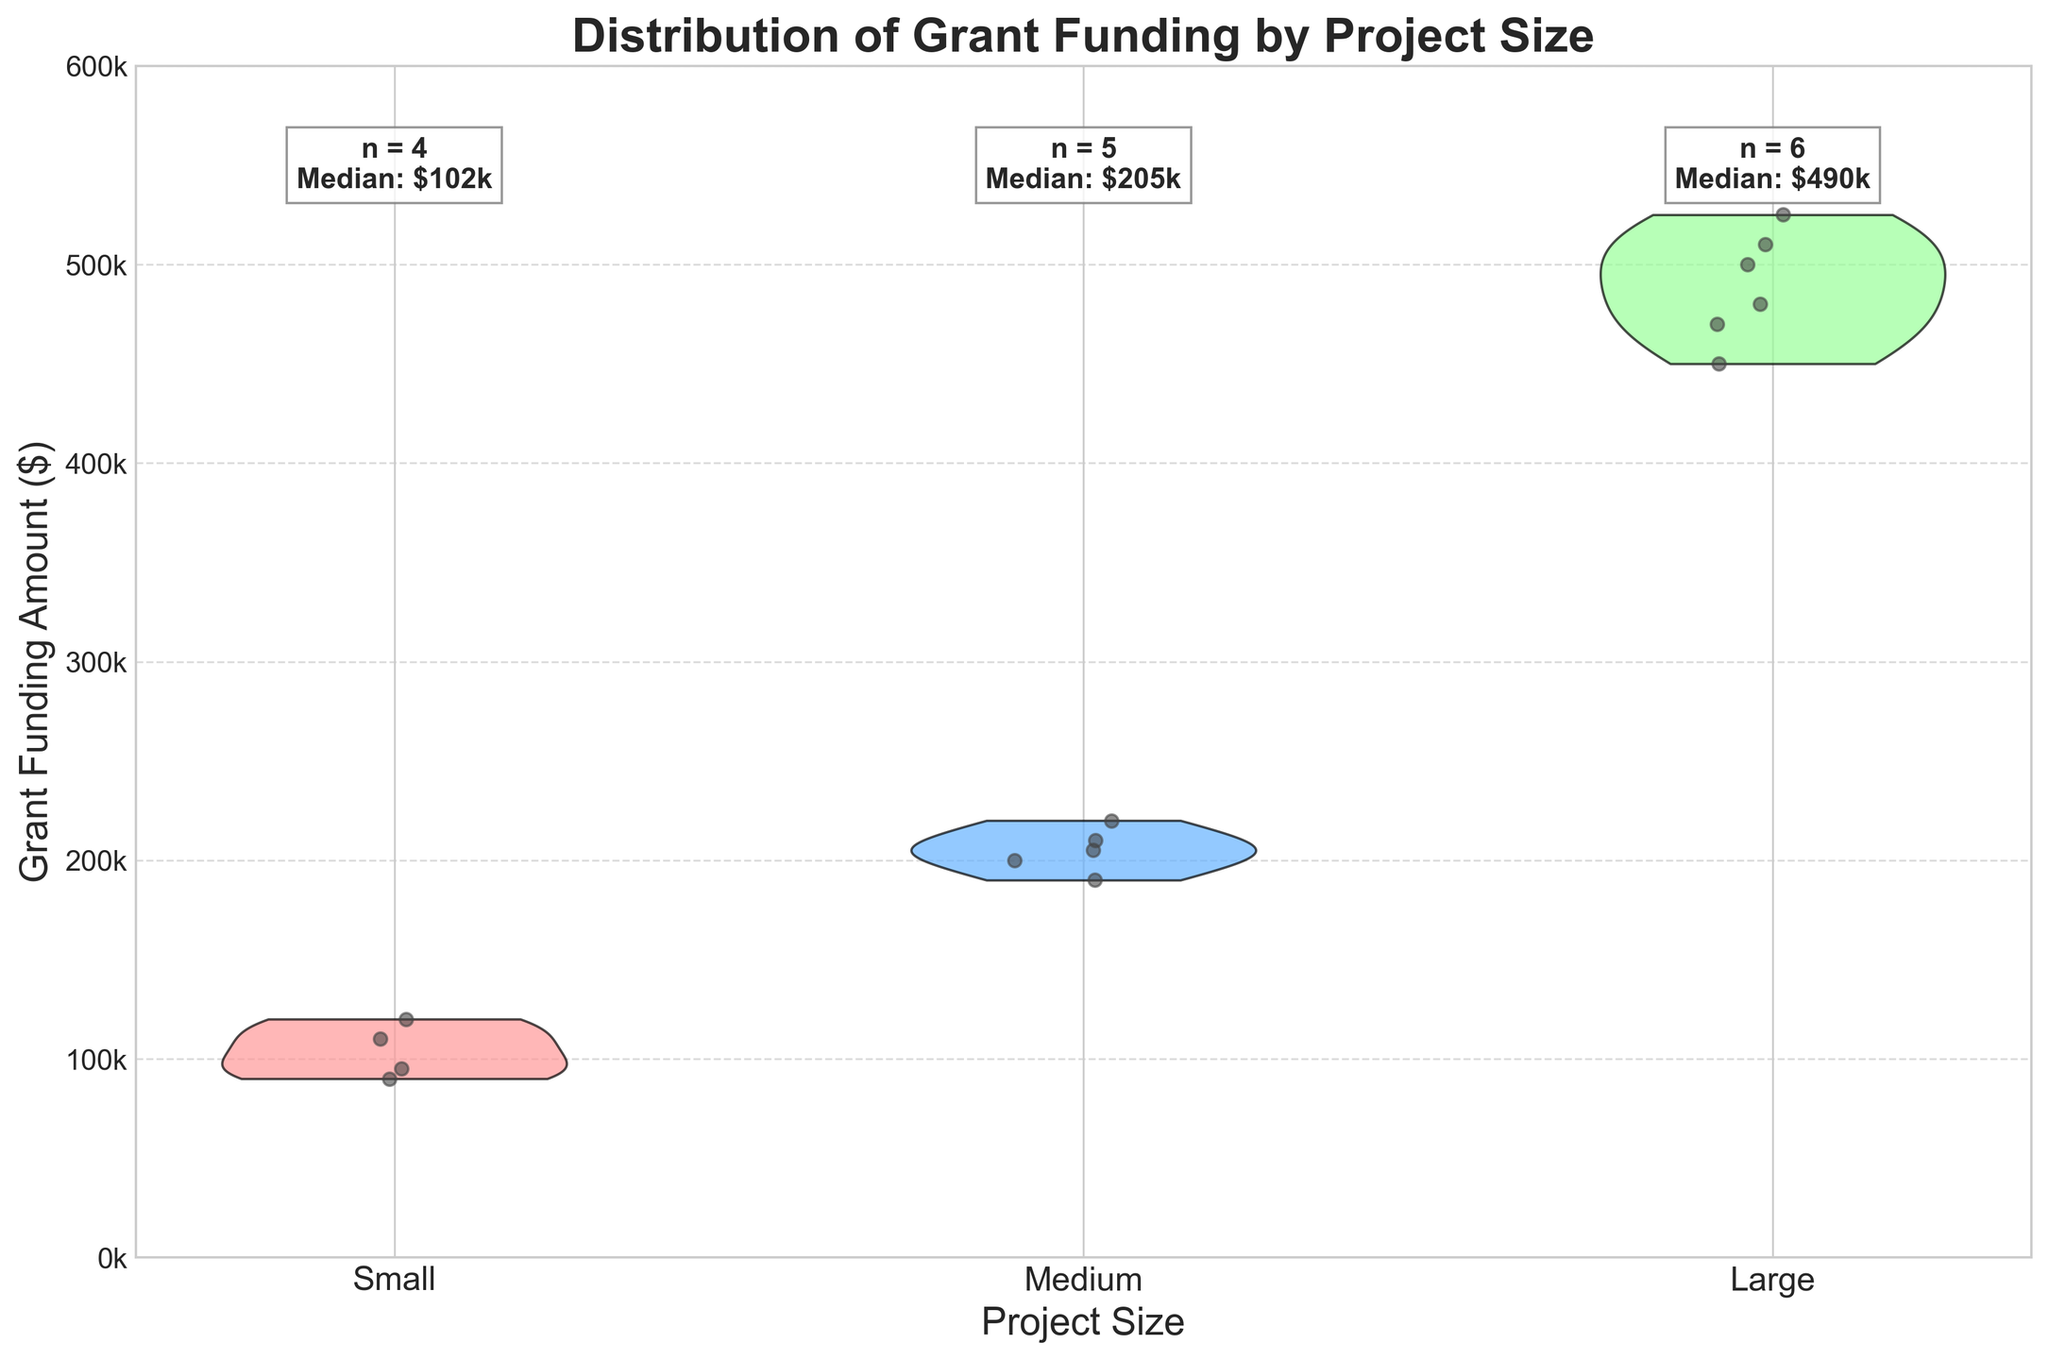How many unique project sizes are represented in the figure? The figure divides projects into three unique categories: Small, Medium, and Large, as shown on the x-axis.
Answer: 3 What is the title of the figure? The title is displayed at the top of the figure, which summarizes the chart's purpose and content.
Answer: Distribution of Grant Funding by Project Size Which project size has the highest median grant funding amount? The text annotations show the median grant amounts for each project size. The large projects have the highest median of \$500k.
Answer: Large What is the grant funding amount for the small project with the highest funding? By looking at the jittered points within the Small category, the highest point appears around the \$120,000 mark.
Answer: \$120,000 How many projects fall under the Medium size category? The text annotation over the medium violin plot mentions the count of projects in this category.
Answer: 5 Which color represents the Medium-sized projects in the plot? The violin plot uses different colors for each project size, with Medium represented by a light blue color.
Answer: Light Blue Is the variation in grant funding larger in Small or Large projects? By observing the spread of the jittered points in the violin plots, it is evident that the Large projects have a wider range of funding amounts compared to Small projects.
Answer: Large What is the range of grant funding amounts for the Large projects? By looking at the jittered points in the Large category violin plot, the lowest funding is around \$450,000, and the highest is about \$525,000.
Answer: \$75,000 What is the total number of projects represented in the figure? Adding up the counts provided in the text annotations for each project size category: 4 (Small) + 5 (Medium) + 6 (Large).
Answer: 15 Which project size has the most diverse range of grant funding, and how can you tell? The Large project size shows the most diverse range of grant funding as indicated by the wider spread of points and the broader shape of the violin plot compared to the other sizes.
Answer: Large 